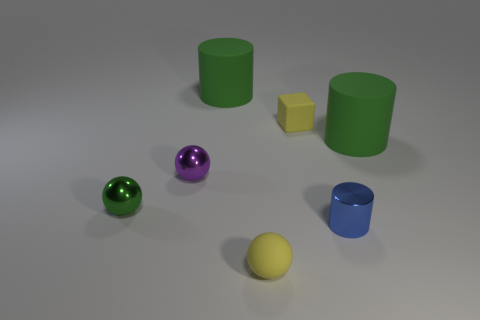Add 1 small brown cylinders. How many objects exist? 8 Subtract all balls. How many objects are left? 4 Add 3 purple metal things. How many purple metal things are left? 4 Add 5 yellow cubes. How many yellow cubes exist? 6 Subtract 0 blue cubes. How many objects are left? 7 Subtract all yellow matte cubes. Subtract all green metallic objects. How many objects are left? 5 